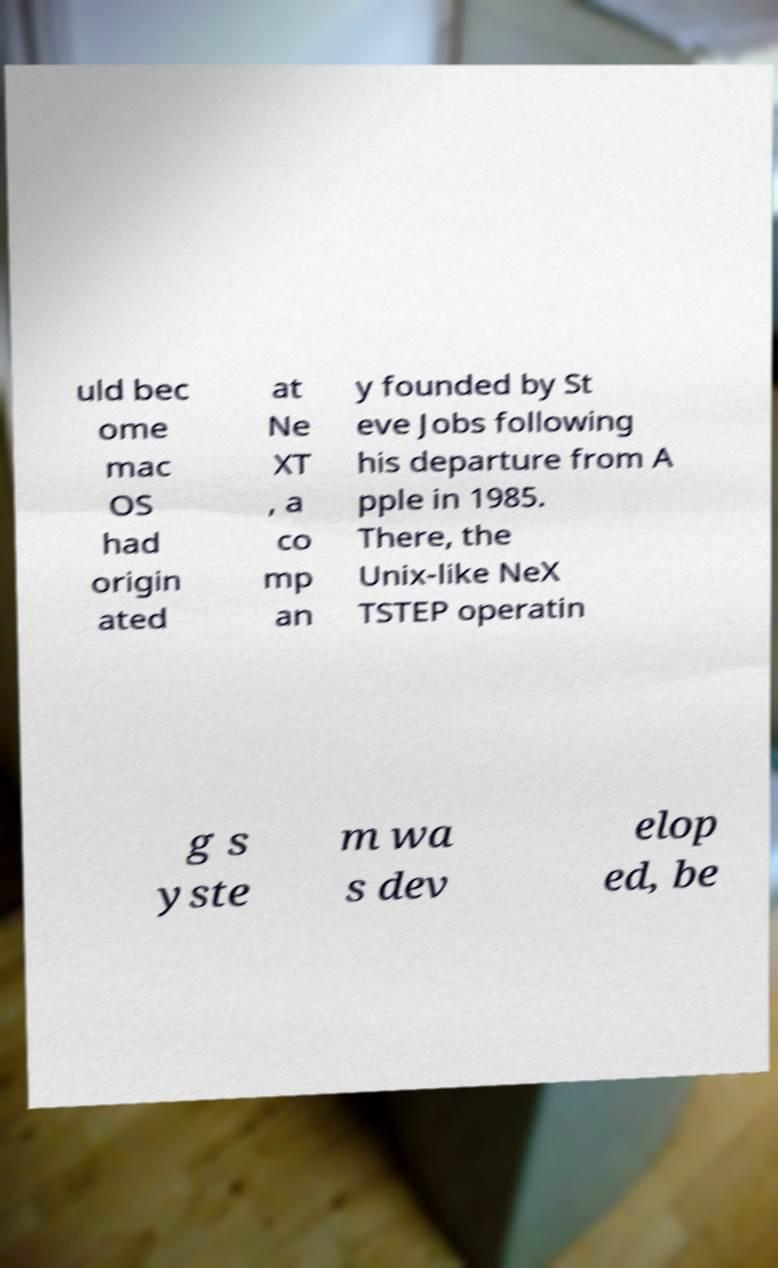What messages or text are displayed in this image? I need them in a readable, typed format. uld bec ome mac OS had origin ated at Ne XT , a co mp an y founded by St eve Jobs following his departure from A pple in 1985. There, the Unix-like NeX TSTEP operatin g s yste m wa s dev elop ed, be 